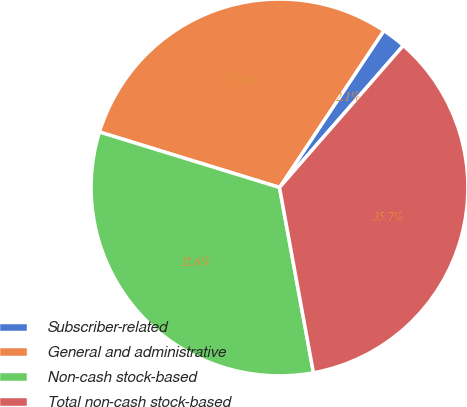Convert chart. <chart><loc_0><loc_0><loc_500><loc_500><pie_chart><fcel>Subscriber-related<fcel>General and administrative<fcel>Non-cash stock-based<fcel>Total non-cash stock-based<nl><fcel>2.07%<fcel>29.59%<fcel>32.64%<fcel>35.7%<nl></chart> 